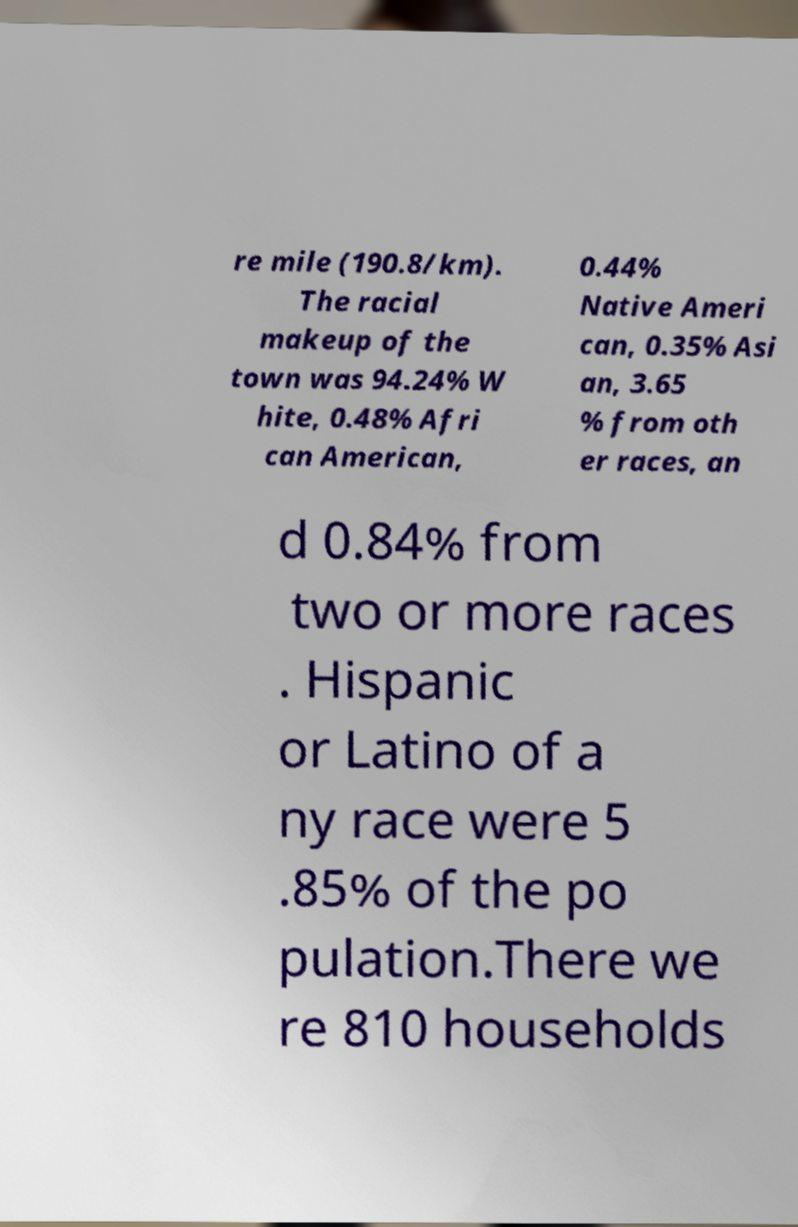I need the written content from this picture converted into text. Can you do that? re mile (190.8/km). The racial makeup of the town was 94.24% W hite, 0.48% Afri can American, 0.44% Native Ameri can, 0.35% Asi an, 3.65 % from oth er races, an d 0.84% from two or more races . Hispanic or Latino of a ny race were 5 .85% of the po pulation.There we re 810 households 